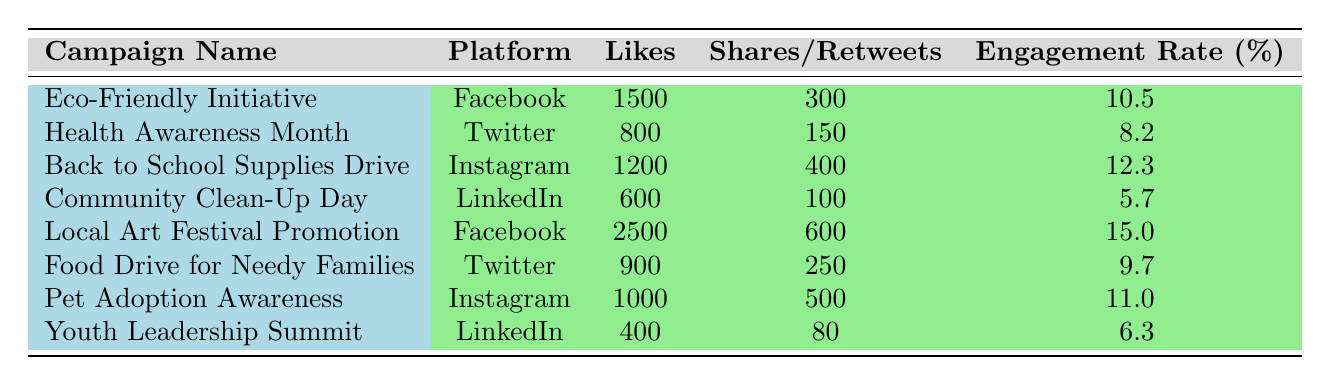What is the total number of likes across all campaigns? To find the total number of likes, we need to add the likes from each campaign: 1500 (Eco-Friendly Initiative) + 800 (Health Awareness Month) + 1200 (Back to School Supplies Drive) + 600 (Community Clean-Up Day) + 2500 (Local Art Festival Promotion) + 900 (Food Drive for Needy Families) + 1000 (Pet Adoption Awareness) + 400 (Youth Leadership Summit) = 8100.
Answer: 8100 Which campaign had the highest engagement rate? By looking through the engagement rates in the table, the Local Art Festival Promotion has the highest engagement rate of 15.0.
Answer: Local Art Festival Promotion Is the engagement rate for the Community Clean-Up Day higher than 7%? The engagement rate for the Community Clean-Up Day is 5.7%, which is lower than 7%.
Answer: No How many shares/retweets did the Back to School Supplies Drive receive? The number of shares for the Back to School Supplies Drive is listed as 400 in the table.
Answer: 400 What is the average engagement rate of all campaigns? To calculate the average engagement rate, add all engagement rates: 10.5 + 8.2 + 12.3 + 5.7 + 15.0 + 9.7 + 11.0 + 6.3 = 79.7. Then divide by the number of campaigns (8): 79.7 / 8 = 9.9625, which rounds to 10%.
Answer: 10% Is there a campaign that received more than 2000 likes? By checking the table, we see that only the Local Art Festival Promotion campaign received 2500 likes, which is greater than 2000.
Answer: Yes What is the difference in likes between the campaign with the most likes and the one with the least likes? The campaign with the most likes is the Local Art Festival Promotion with 2500 likes, and the one with the least is the Community Clean-Up Day with 600 likes. The difference is 2500 - 600 = 1900.
Answer: 1900 Which platform had the least total engagement across all campaigns? To determine the platform with the least engagement, we sum the engagement rates of campaigns by platform: Facebook (10.5 + 15.0), Twitter (8.2 + 9.7), Instagram (12.3 + 11.0), LinkedIn (5.7 + 6.3). This gives us: Facebook = 25.5, Twitter = 17.9, Instagram = 23.3, LinkedIn = 12.0. The least is LinkedIn with 12.0.
Answer: LinkedIn 